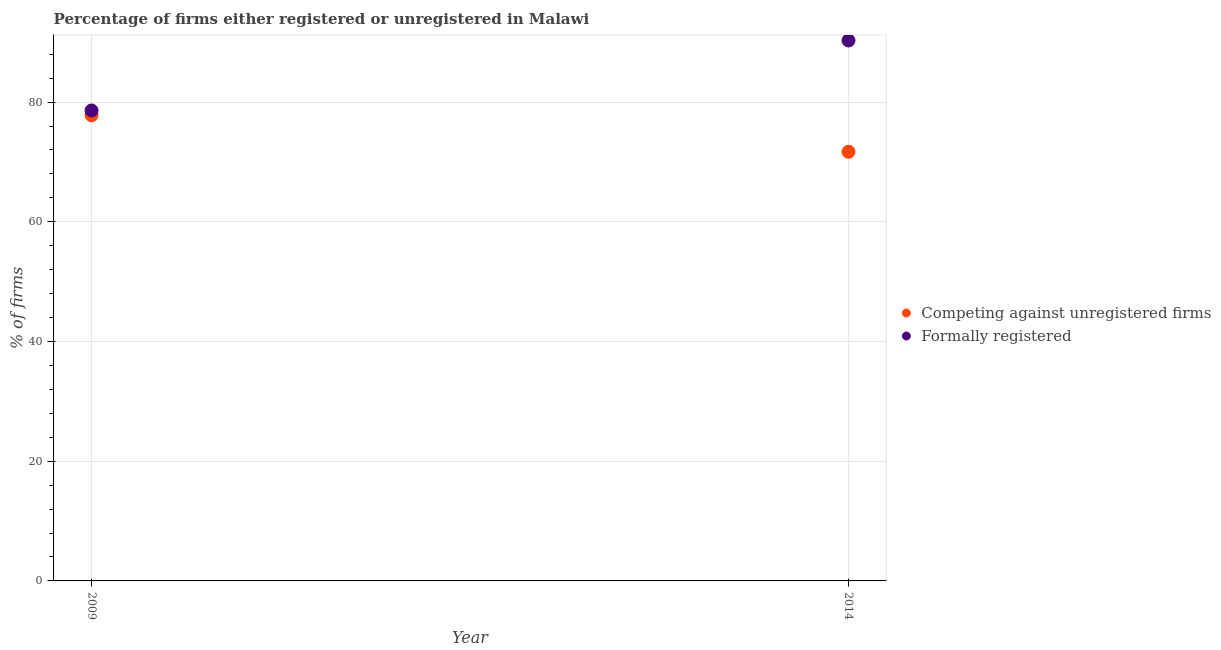What is the percentage of formally registered firms in 2009?
Ensure brevity in your answer.  78.6. Across all years, what is the maximum percentage of formally registered firms?
Provide a succinct answer. 90.3. Across all years, what is the minimum percentage of formally registered firms?
Ensure brevity in your answer.  78.6. In which year was the percentage of registered firms minimum?
Offer a very short reply. 2014. What is the total percentage of registered firms in the graph?
Give a very brief answer. 149.5. What is the difference between the percentage of registered firms in 2009 and that in 2014?
Offer a terse response. 6.1. What is the difference between the percentage of registered firms in 2014 and the percentage of formally registered firms in 2009?
Provide a succinct answer. -6.9. What is the average percentage of formally registered firms per year?
Offer a very short reply. 84.45. In the year 2009, what is the difference between the percentage of formally registered firms and percentage of registered firms?
Provide a short and direct response. 0.8. What is the ratio of the percentage of formally registered firms in 2009 to that in 2014?
Keep it short and to the point. 0.87. In how many years, is the percentage of registered firms greater than the average percentage of registered firms taken over all years?
Provide a succinct answer. 1. Is the percentage of formally registered firms strictly less than the percentage of registered firms over the years?
Your response must be concise. No. How many dotlines are there?
Offer a very short reply. 2. What is the difference between two consecutive major ticks on the Y-axis?
Your response must be concise. 20. Are the values on the major ticks of Y-axis written in scientific E-notation?
Provide a short and direct response. No. Does the graph contain any zero values?
Provide a short and direct response. No. How are the legend labels stacked?
Your response must be concise. Vertical. What is the title of the graph?
Make the answer very short. Percentage of firms either registered or unregistered in Malawi. What is the label or title of the X-axis?
Your response must be concise. Year. What is the label or title of the Y-axis?
Keep it short and to the point. % of firms. What is the % of firms of Competing against unregistered firms in 2009?
Provide a succinct answer. 77.8. What is the % of firms of Formally registered in 2009?
Your answer should be very brief. 78.6. What is the % of firms of Competing against unregistered firms in 2014?
Keep it short and to the point. 71.7. What is the % of firms of Formally registered in 2014?
Offer a terse response. 90.3. Across all years, what is the maximum % of firms of Competing against unregistered firms?
Ensure brevity in your answer.  77.8. Across all years, what is the maximum % of firms of Formally registered?
Offer a very short reply. 90.3. Across all years, what is the minimum % of firms of Competing against unregistered firms?
Your response must be concise. 71.7. Across all years, what is the minimum % of firms of Formally registered?
Your answer should be very brief. 78.6. What is the total % of firms of Competing against unregistered firms in the graph?
Keep it short and to the point. 149.5. What is the total % of firms in Formally registered in the graph?
Provide a short and direct response. 168.9. What is the average % of firms of Competing against unregistered firms per year?
Ensure brevity in your answer.  74.75. What is the average % of firms of Formally registered per year?
Provide a short and direct response. 84.45. In the year 2014, what is the difference between the % of firms of Competing against unregistered firms and % of firms of Formally registered?
Make the answer very short. -18.6. What is the ratio of the % of firms of Competing against unregistered firms in 2009 to that in 2014?
Provide a short and direct response. 1.09. What is the ratio of the % of firms in Formally registered in 2009 to that in 2014?
Give a very brief answer. 0.87. What is the difference between the highest and the second highest % of firms in Competing against unregistered firms?
Your answer should be very brief. 6.1. 